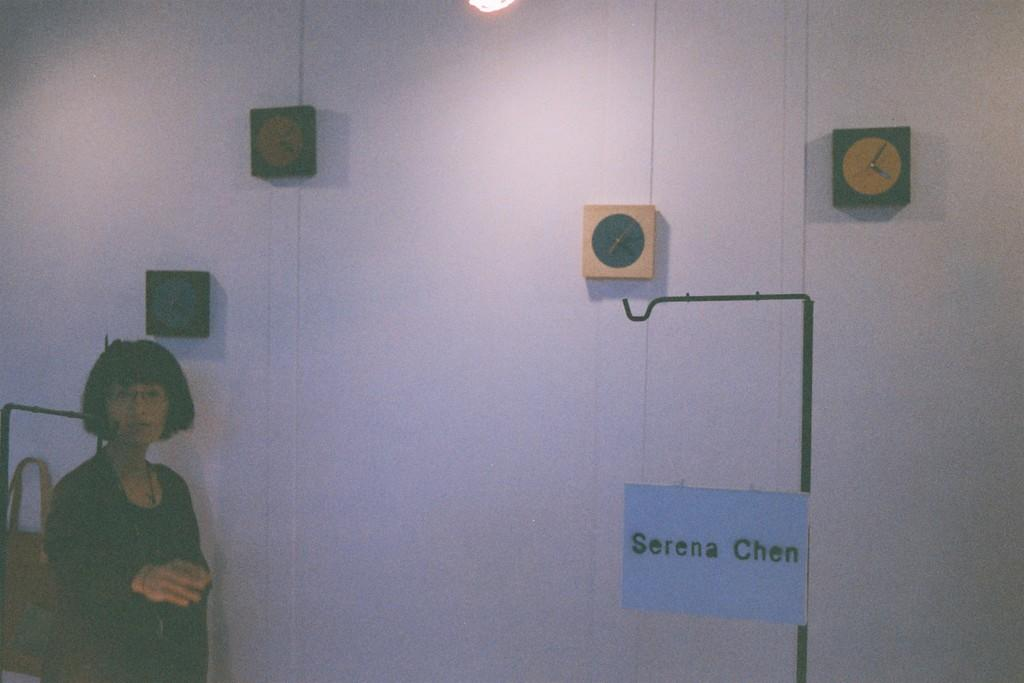Where is the woman located in the image? The woman is in the bottom left of the image. What can be seen in the center of the image? There is a wall with clocks and text in the center of the image. How does the boy compare to the clocks on the wall in the image? There is no boy present in the image, so it is not possible to make a comparison. 